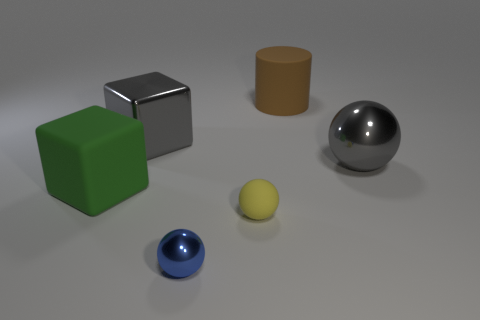How many cubes are the same color as the big metal sphere?
Your answer should be very brief. 1. There is a metal ball that is to the right of the cylinder; is its color the same as the big metallic cube?
Provide a succinct answer. Yes. What number of cubes are either brown things or green things?
Provide a succinct answer. 1. How big is the gray metallic thing that is right of the small ball behind the small blue object in front of the small yellow sphere?
Keep it short and to the point. Large. The other matte object that is the same size as the brown rubber thing is what shape?
Give a very brief answer. Cube. What is the shape of the blue metal thing?
Make the answer very short. Sphere. Is the big object behind the big gray block made of the same material as the big ball?
Provide a short and direct response. No. What size is the shiny ball that is to the right of the metal ball that is in front of the green cube?
Offer a terse response. Large. There is a matte object that is right of the rubber cube and in front of the gray metal sphere; what is its color?
Make the answer very short. Yellow. There is a object that is the same size as the rubber ball; what is it made of?
Your answer should be very brief. Metal. 